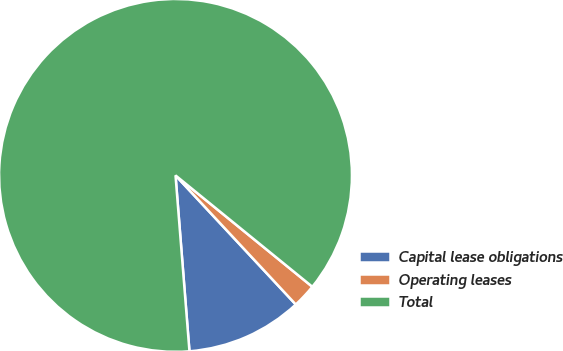<chart> <loc_0><loc_0><loc_500><loc_500><pie_chart><fcel>Capital lease obligations<fcel>Operating leases<fcel>Total<nl><fcel>10.68%<fcel>2.19%<fcel>87.13%<nl></chart> 